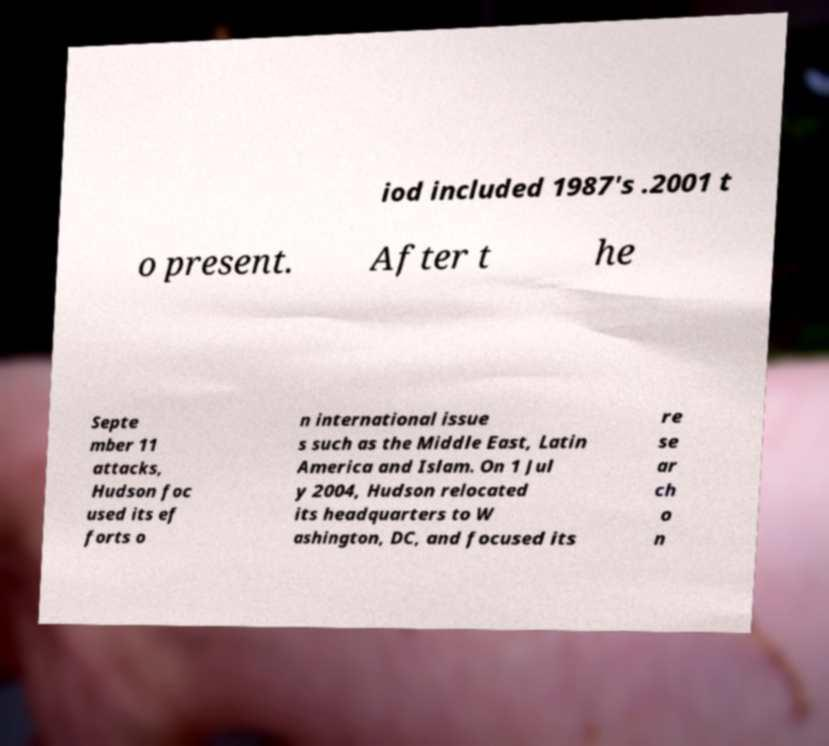Please read and relay the text visible in this image. What does it say? iod included 1987's .2001 t o present. After t he Septe mber 11 attacks, Hudson foc used its ef forts o n international issue s such as the Middle East, Latin America and Islam. On 1 Jul y 2004, Hudson relocated its headquarters to W ashington, DC, and focused its re se ar ch o n 